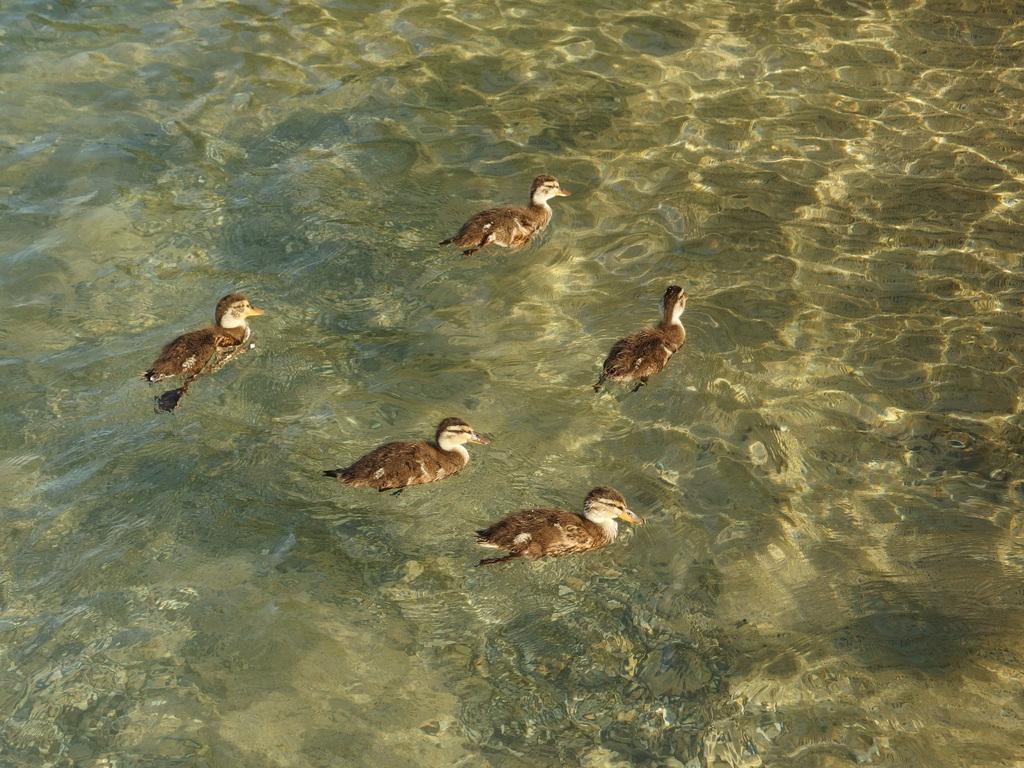Describe this image in one or two sentences. This picture might be taken in a lake. In this image, we can see few ducks which are drowning on the water and the background, we can see water in the lake. 